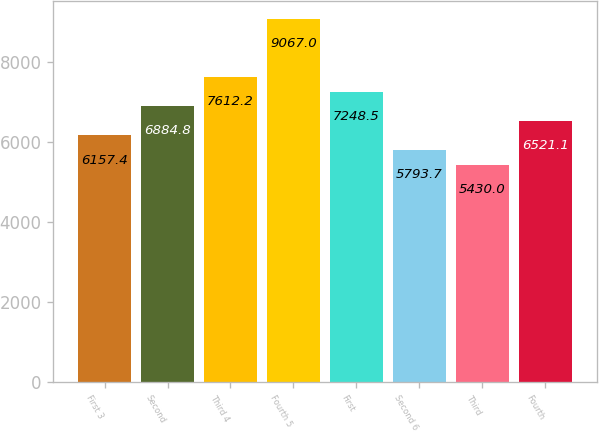Convert chart. <chart><loc_0><loc_0><loc_500><loc_500><bar_chart><fcel>First 3<fcel>Second<fcel>Third 4<fcel>Fourth 5<fcel>First<fcel>Second 6<fcel>Third<fcel>Fourth<nl><fcel>6157.4<fcel>6884.8<fcel>7612.2<fcel>9067<fcel>7248.5<fcel>5793.7<fcel>5430<fcel>6521.1<nl></chart> 